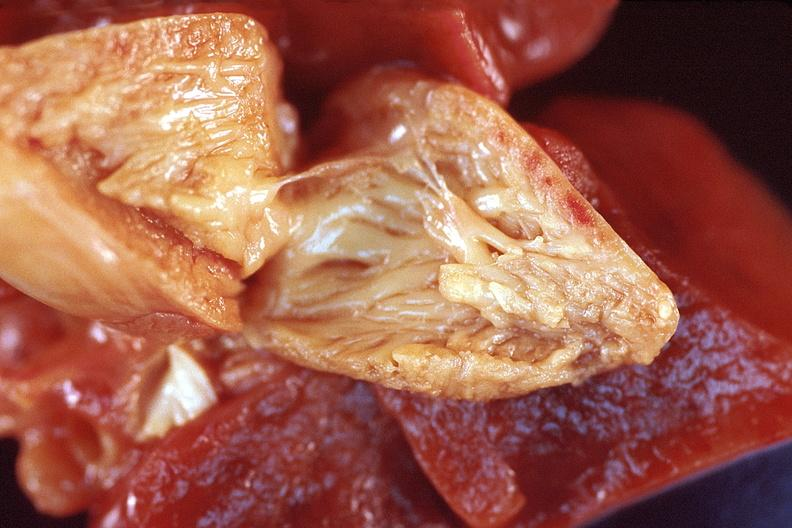where is this?
Answer the question using a single word or phrase. Heart 